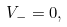<formula> <loc_0><loc_0><loc_500><loc_500>V _ { - } = 0 ,</formula> 